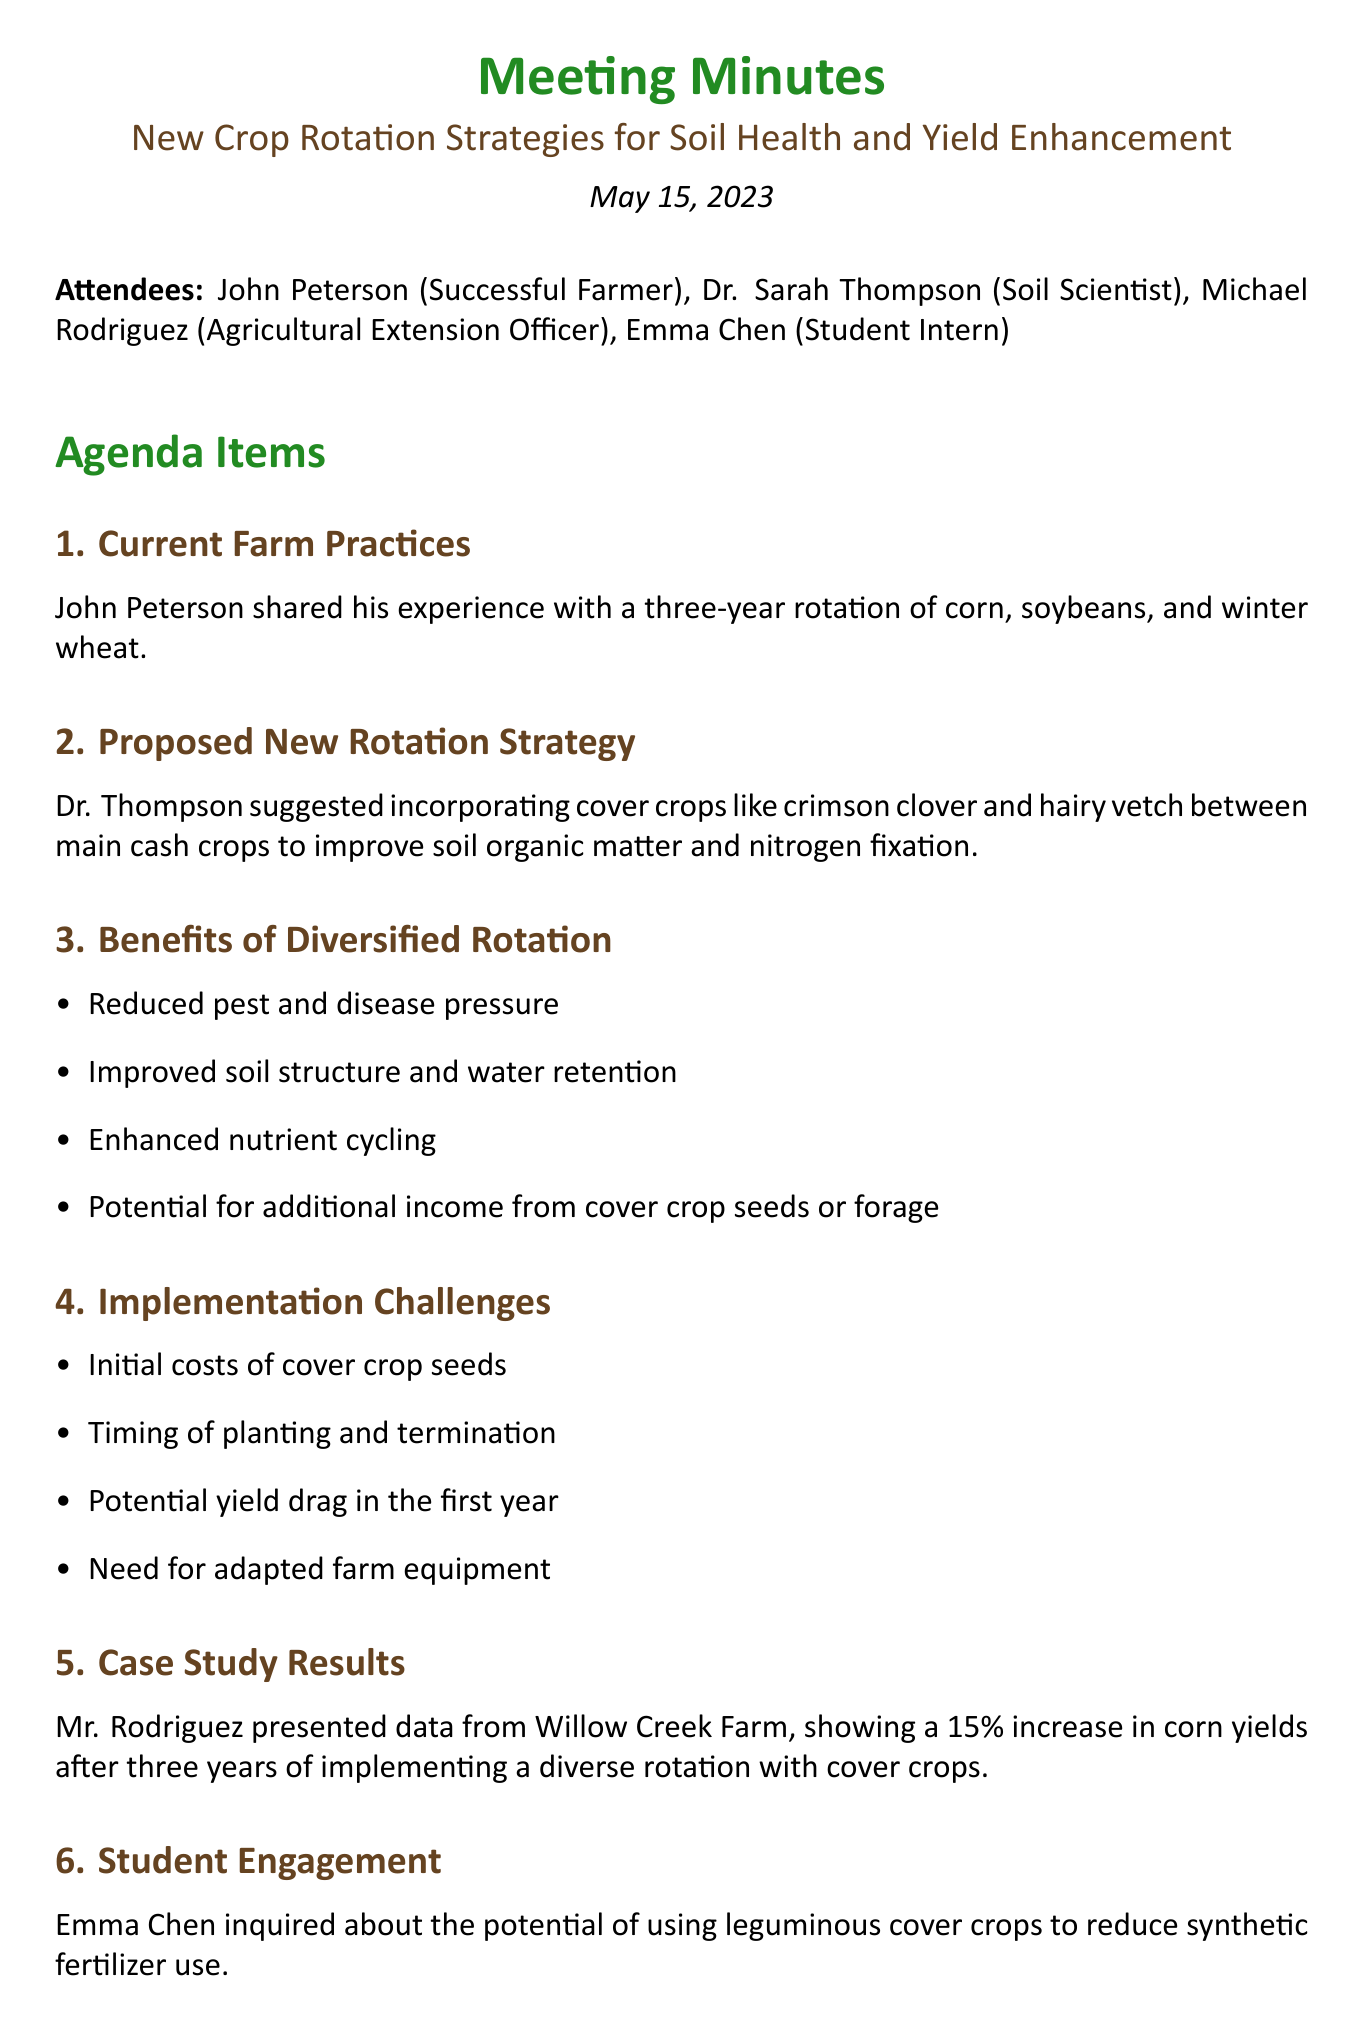What is the date of the meeting? The date of the meeting is mentioned in the document.
Answer: May 15, 2023 Who suggested incorporating cover crops? The document states the name of the person who proposed the new rotation strategy.
Answer: Dr. Sarah Thompson What crop was included in the current farm practices? The document lists the crops involved in John's three-year rotation.
Answer: Corn, soybeans, winter wheat What is one benefit of a diversified rotation? The document outlines several benefits; any can be valid, but one is specifically highlighted.
Answer: Reduced pest and disease pressure What are the initial costs mentioned in the implementation challenges? The discussion includes details about financial aspects related to new practices.
Answer: Cover crop seeds How much increase in corn yields was reported from Willow Creek Farm? The case study results present specific yield increases related to the rotation strategy.
Answer: 15% What will John designate for a pilot project? The next steps include a specific mention of land allocation for new strategies.
Answer: 20 acres Who will organize a field day for other farmers? The document outlines responsibilities for follow-up actions, naming the organizer.
Answer: Michael 